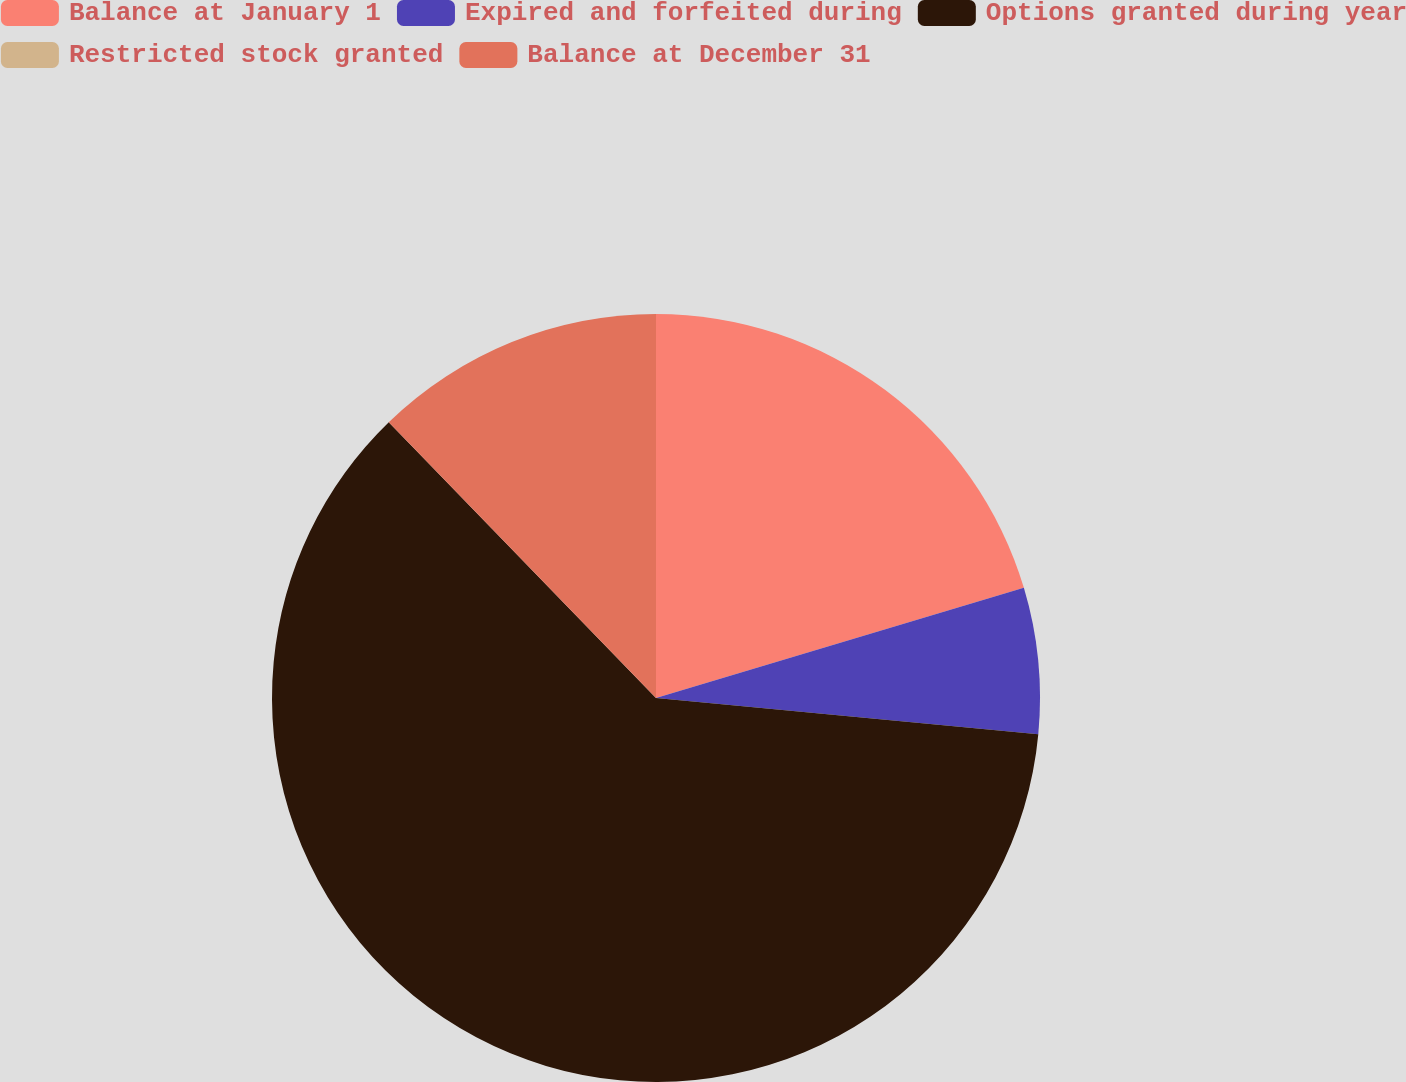Convert chart to OTSL. <chart><loc_0><loc_0><loc_500><loc_500><pie_chart><fcel>Balance at January 1<fcel>Expired and forfeited during<fcel>Options granted during year<fcel>Restricted stock granted<fcel>Balance at December 31<nl><fcel>20.37%<fcel>6.13%<fcel>61.25%<fcel>0.0%<fcel>12.25%<nl></chart> 